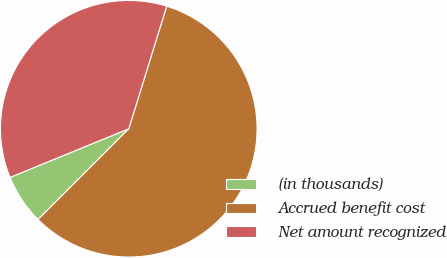Convert chart to OTSL. <chart><loc_0><loc_0><loc_500><loc_500><pie_chart><fcel>(in thousands)<fcel>Accrued benefit cost<fcel>Net amount recognized<nl><fcel>6.31%<fcel>57.73%<fcel>35.97%<nl></chart> 